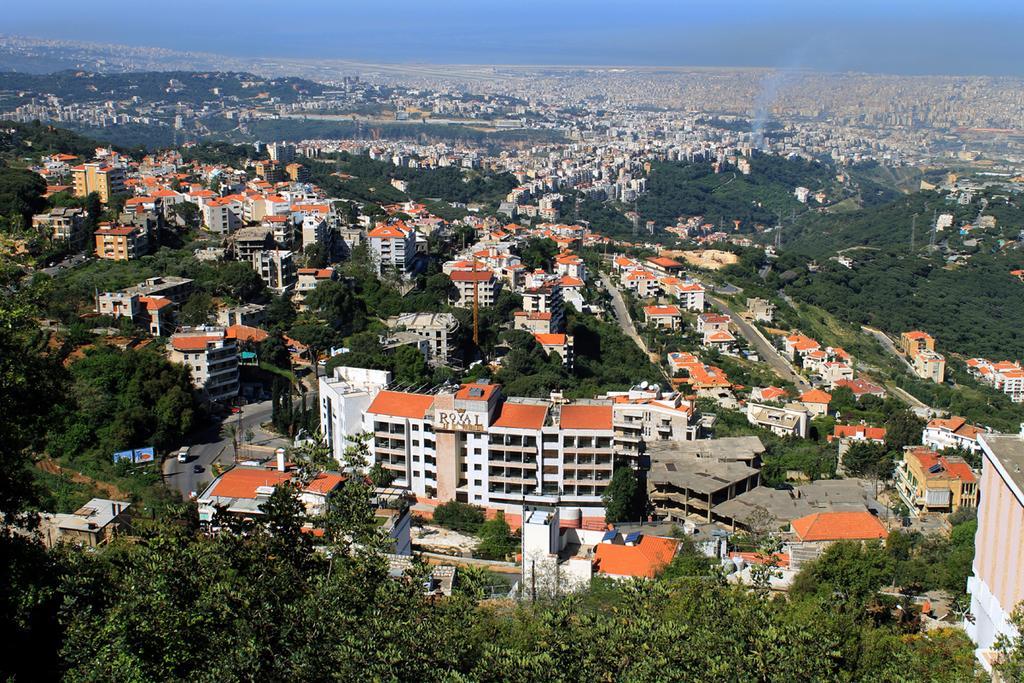Please provide a concise description of this image. In this image we can see some trees, houses, buildings and in the background of the image there is clear sky. 